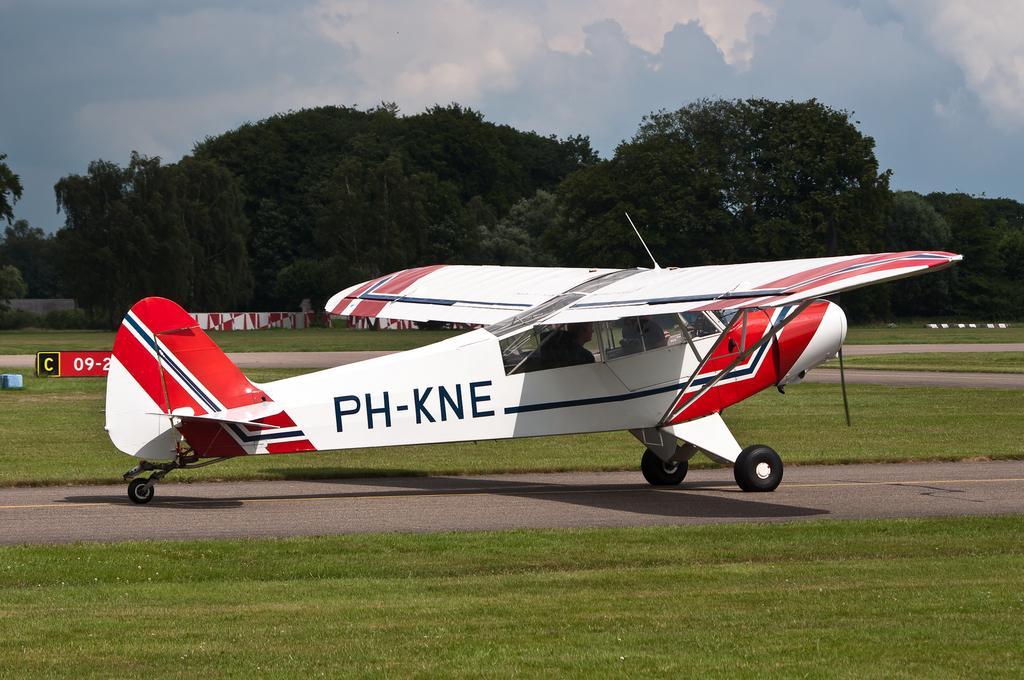In one or two sentences, can you explain what this image depicts? In this image I can see an open grass ground and on it I can see a white colour aircraft. On the left side of this image I can see a board and on it I can see something is written. In the background I can see number of trees, clouds and the sky. 